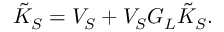<formula> <loc_0><loc_0><loc_500><loc_500>\tilde { K } _ { S } = V _ { S } + V _ { S } G _ { L } \tilde { K } _ { S } .</formula> 